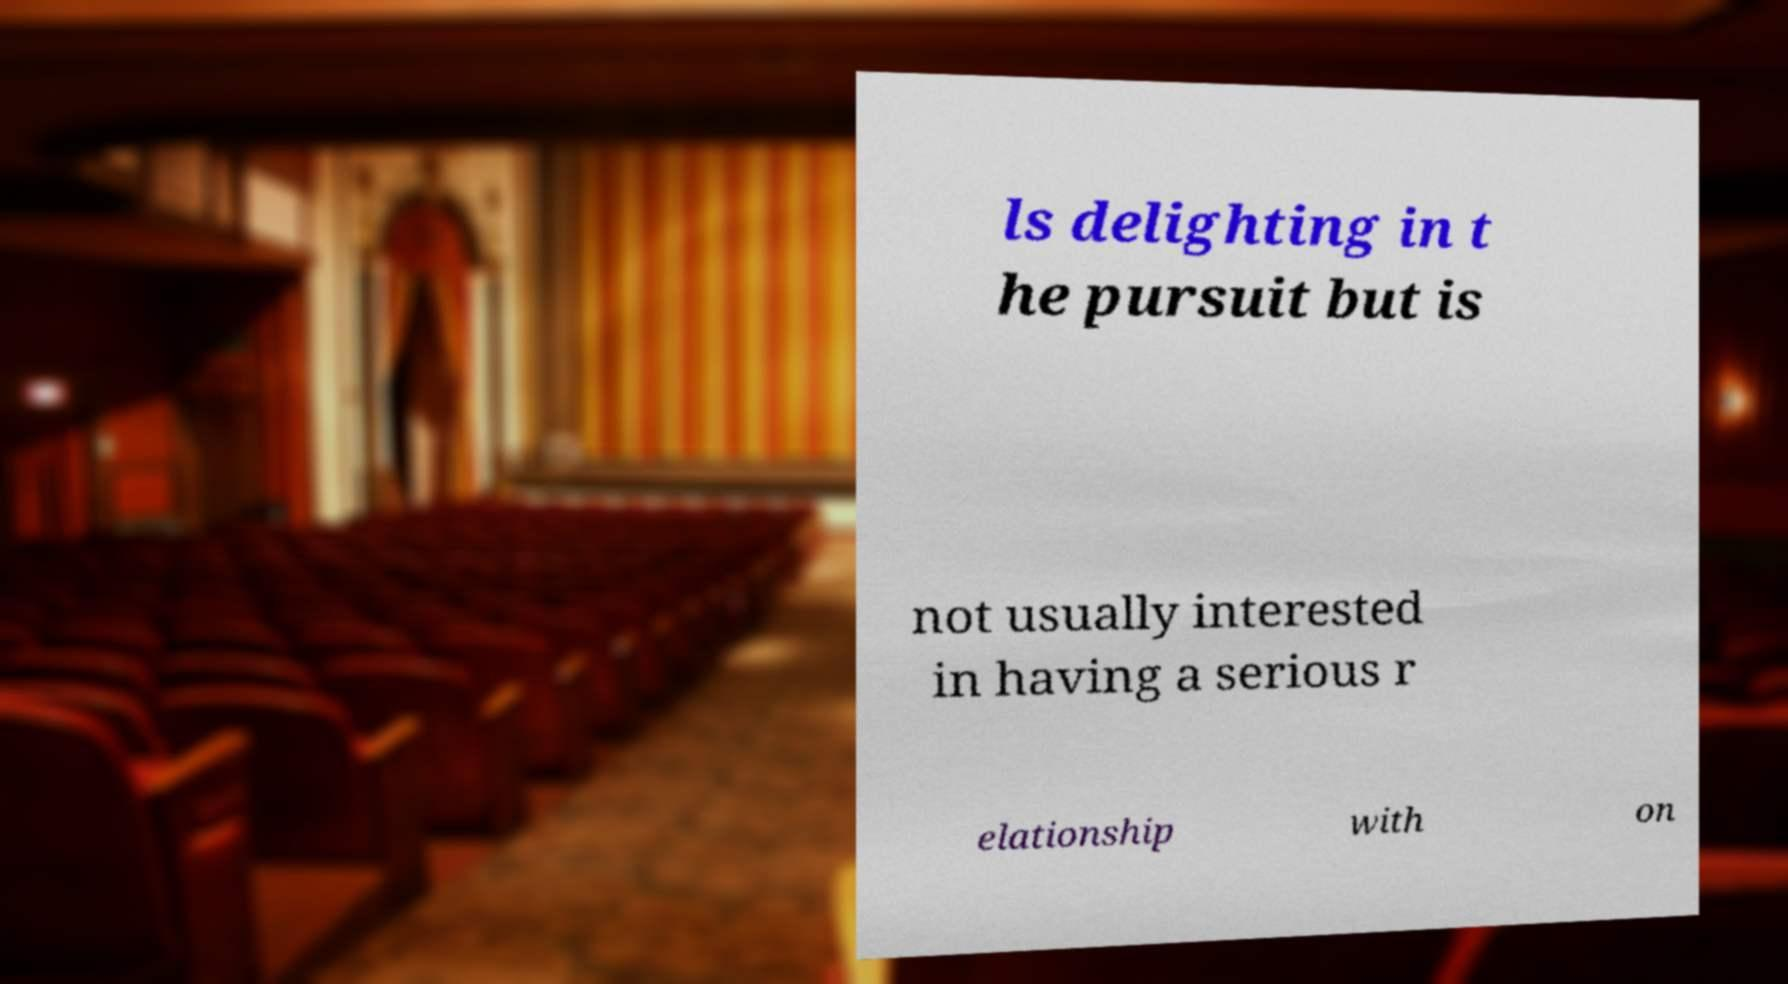I need the written content from this picture converted into text. Can you do that? ls delighting in t he pursuit but is not usually interested in having a serious r elationship with on 